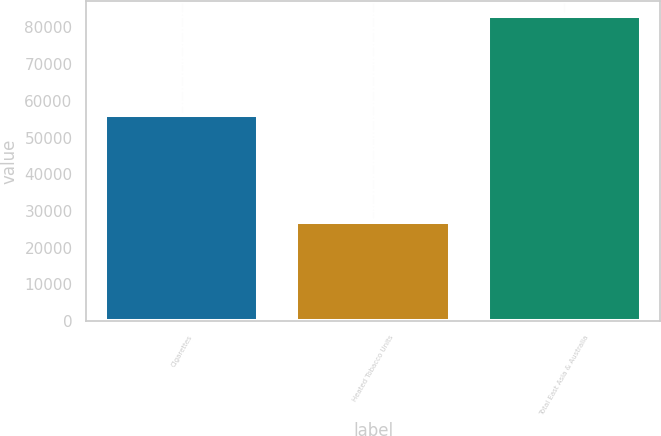Convert chart. <chart><loc_0><loc_0><loc_500><loc_500><bar_chart><fcel>Cigarettes<fcel>Heated Tobacco Units<fcel>Total East Asia & Australia<nl><fcel>56163<fcel>26866<fcel>83029<nl></chart> 